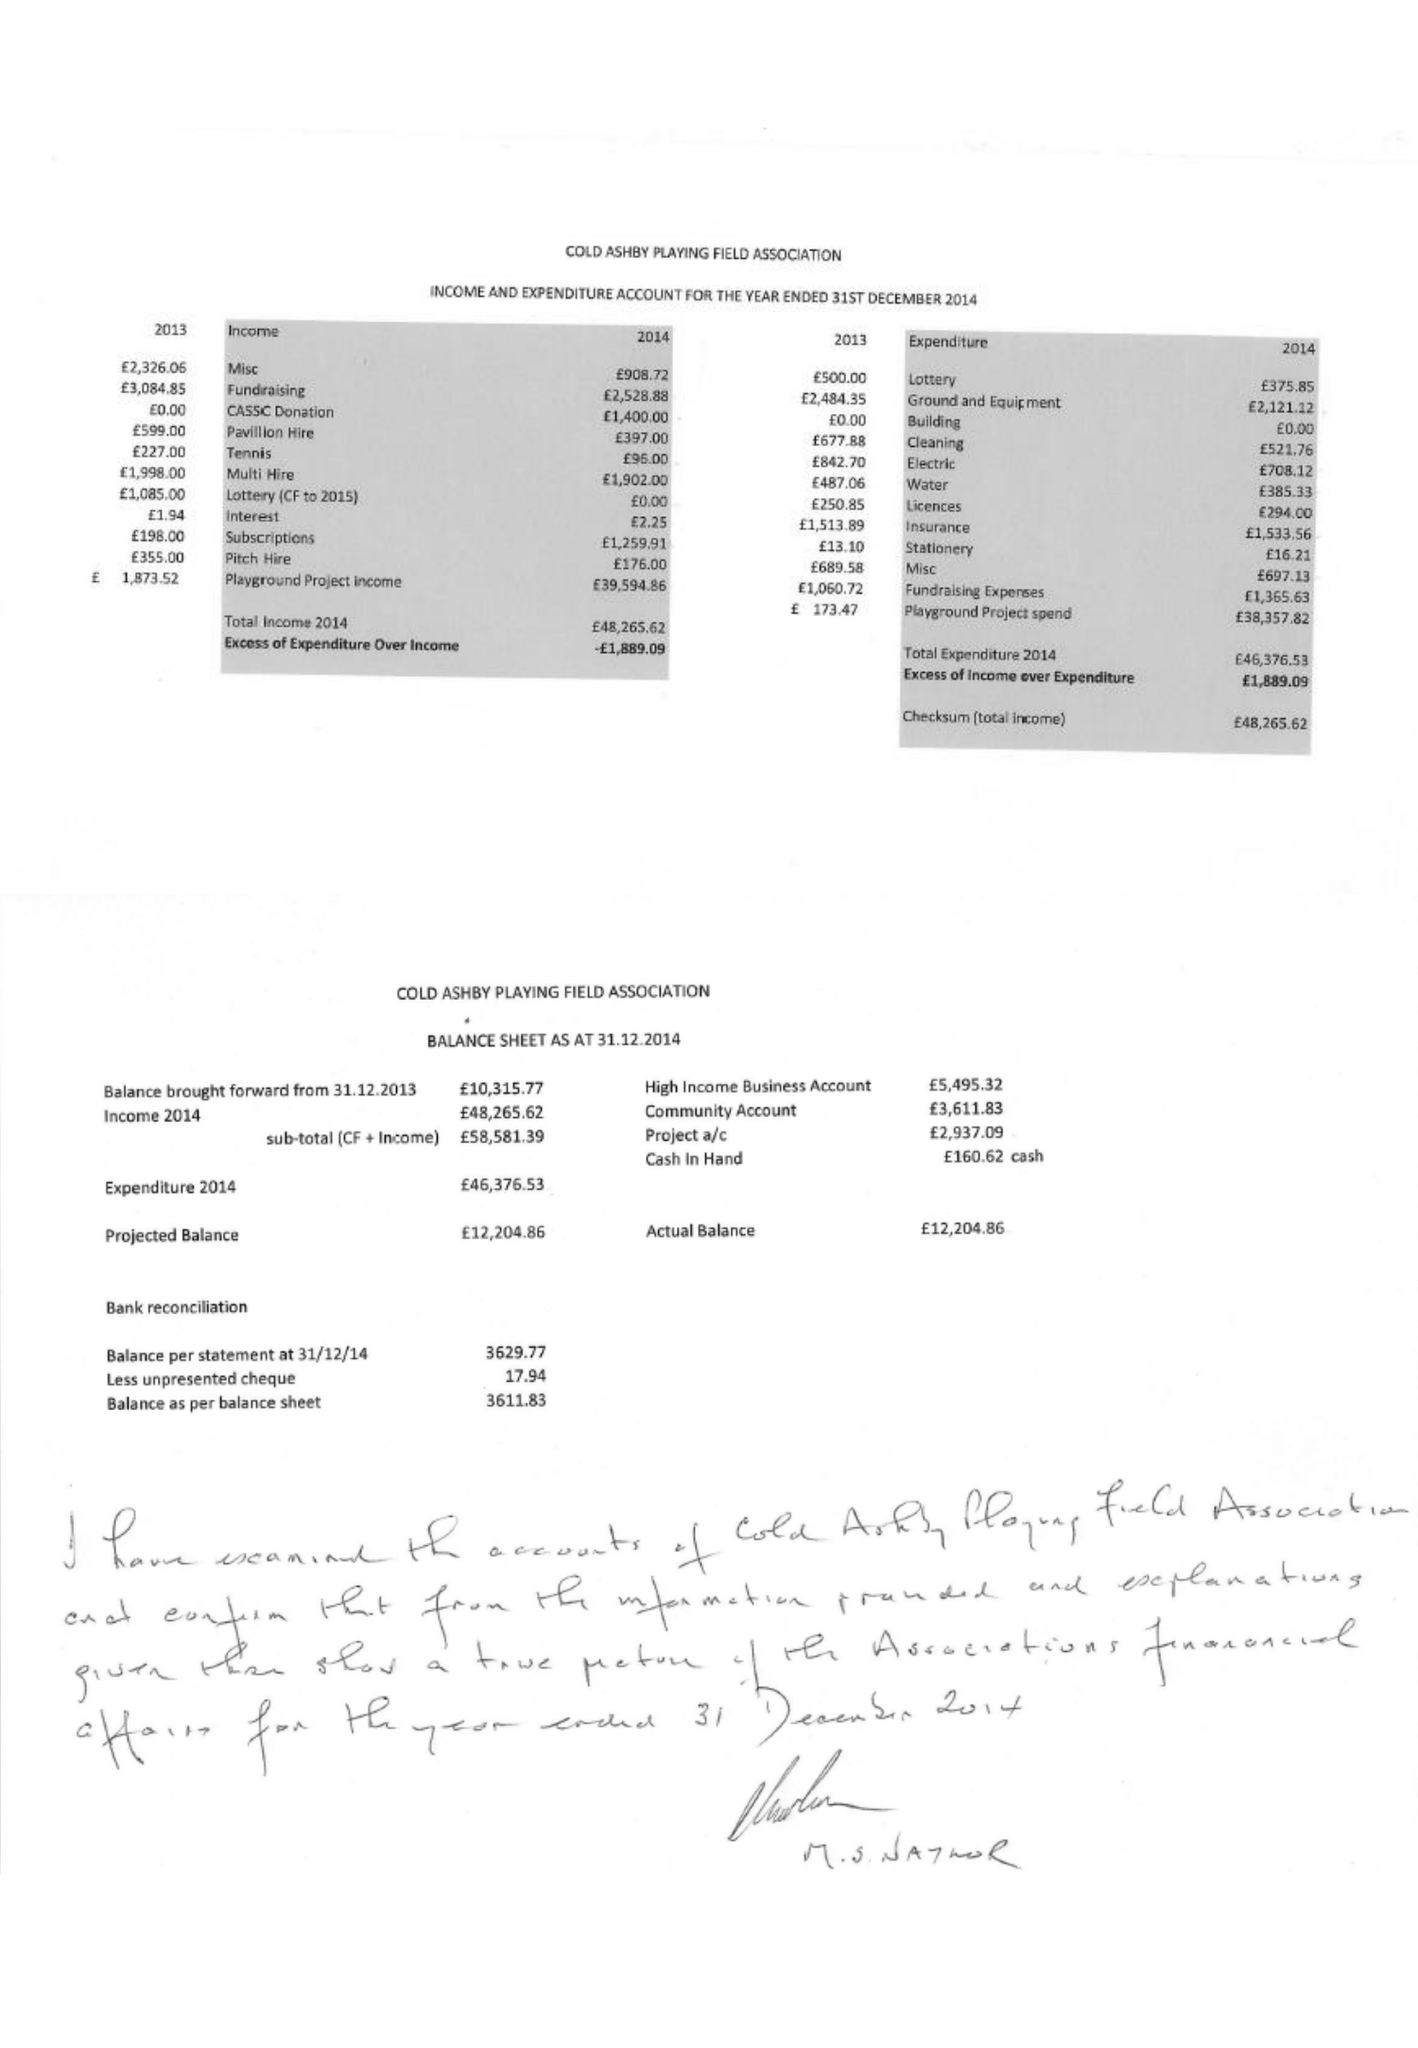What is the value for the address__post_town?
Answer the question using a single word or phrase. NORTHAMPTON 